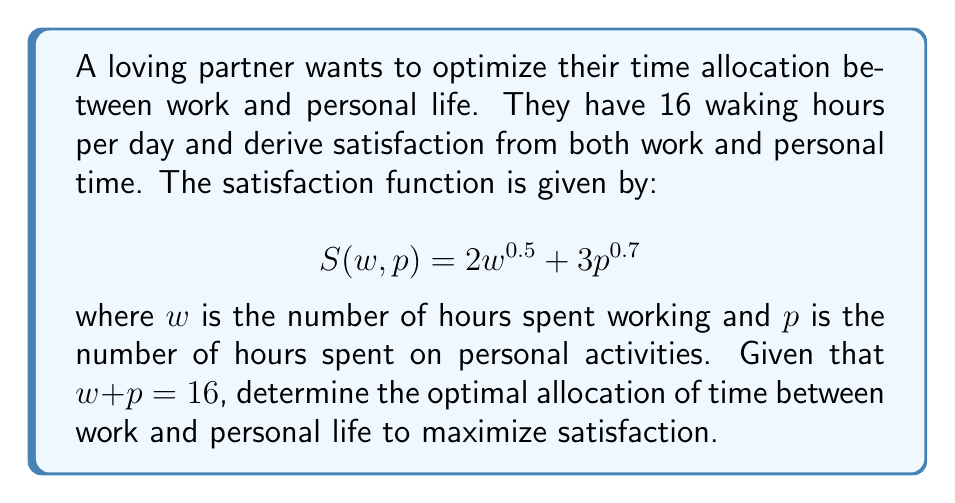Give your solution to this math problem. 1. We need to maximize $S(w, p)$ subject to the constraint $w + p = 16$.

2. Substitute $p = 16 - w$ into the satisfaction function:
   $$S(w) = 2w^{0.5} + 3(16-w)^{0.7}$$

3. To find the maximum, differentiate $S(w)$ with respect to $w$ and set it to zero:
   $$\frac{dS}{dw} = w^{-0.5} - 2.1(16-w)^{-0.3} = 0$$

4. Solve this equation numerically using Newton's method:
   Let $f(w) = w^{-0.5} - 2.1(16-w)^{-0.3}$
   Let $f'(w) = -0.5w^{-1.5} - 0.63(16-w)^{-1.3}$

   Starting with $w_0 = 8$, apply the iteration:
   $$w_{n+1} = w_n - \frac{f(w_n)}{f'(w_n)}$$

5. After a few iterations, we converge to $w \approx 6.4$ hours.

6. Therefore, $p = 16 - 6.4 = 9.6$ hours.

7. Round to the nearest quarter hour for practicality:
   Work time: 6.5 hours
   Personal time: 9.5 hours
Answer: 6.5 hours work, 9.5 hours personal time 